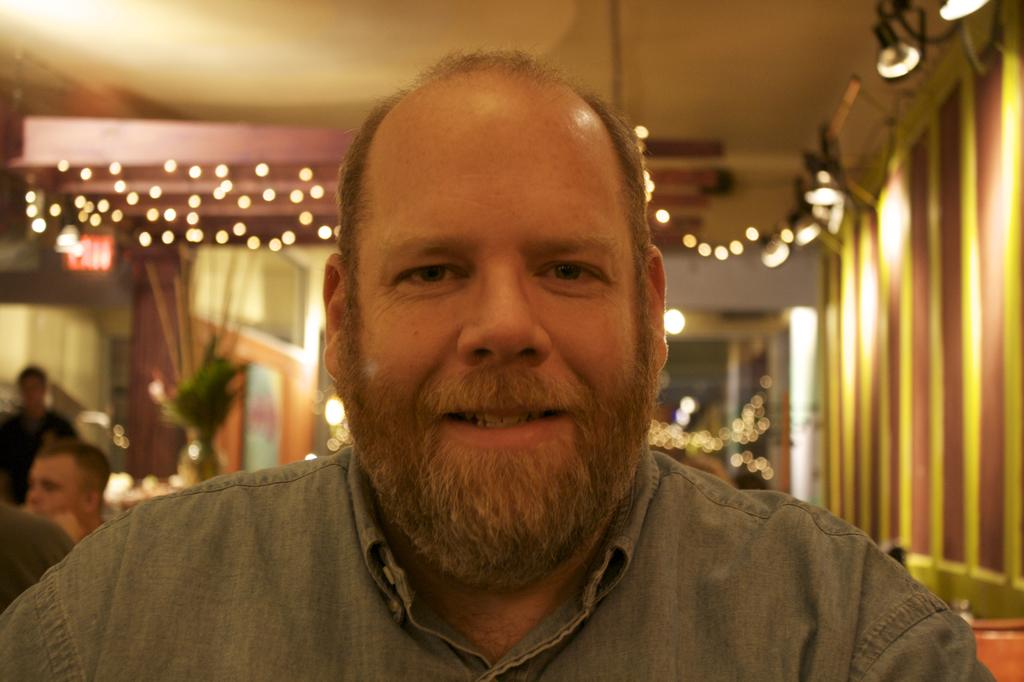What is the main subject of the image? There is a person wearing clothes in the image. What can be seen in the middle of the image? There are lights in the middle of the image. What is located at the top of the image? There is a ceiling at the top of the image. How would you describe the background of the image? The background of the image is blurred. What type of quince is being served at the event in the image? There is no event or quince present in the image; it features a person wearing clothes with lights and a ceiling in the background. 